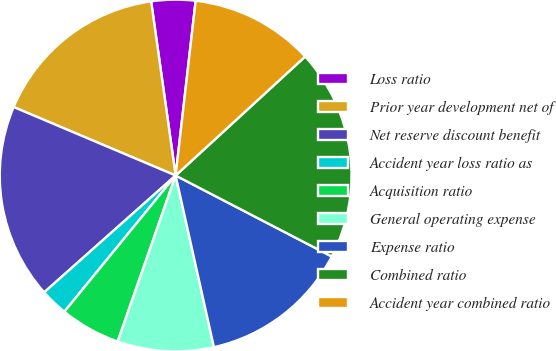<chart> <loc_0><loc_0><loc_500><loc_500><pie_chart><fcel>Loss ratio<fcel>Prior year development net of<fcel>Net reserve discount benefit<fcel>Accident year loss ratio as<fcel>Acquisition ratio<fcel>General operating expense<fcel>Expense ratio<fcel>Combined ratio<fcel>Accident year combined ratio<nl><fcel>4.04%<fcel>16.41%<fcel>17.93%<fcel>2.53%<fcel>5.56%<fcel>8.84%<fcel>13.89%<fcel>19.44%<fcel>11.36%<nl></chart> 